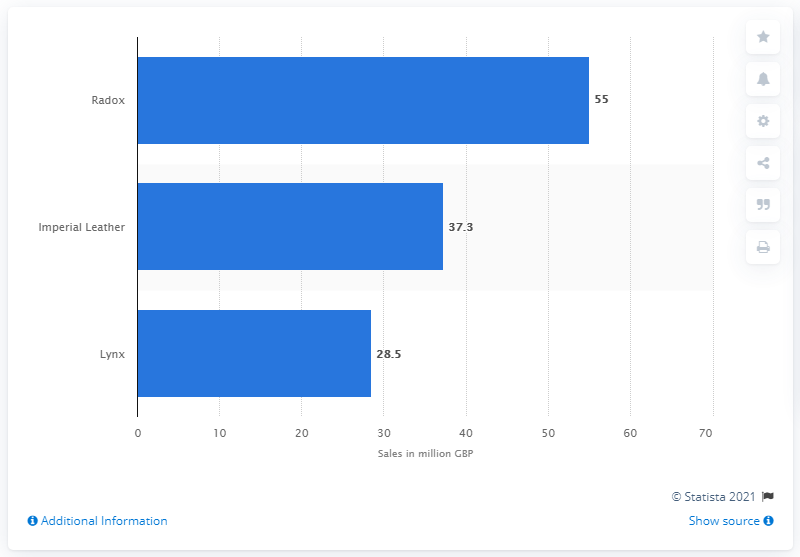Mention a couple of crucial points in this snapshot. Radox is the top brand of shower personal care products sold in the United Kingdom. 